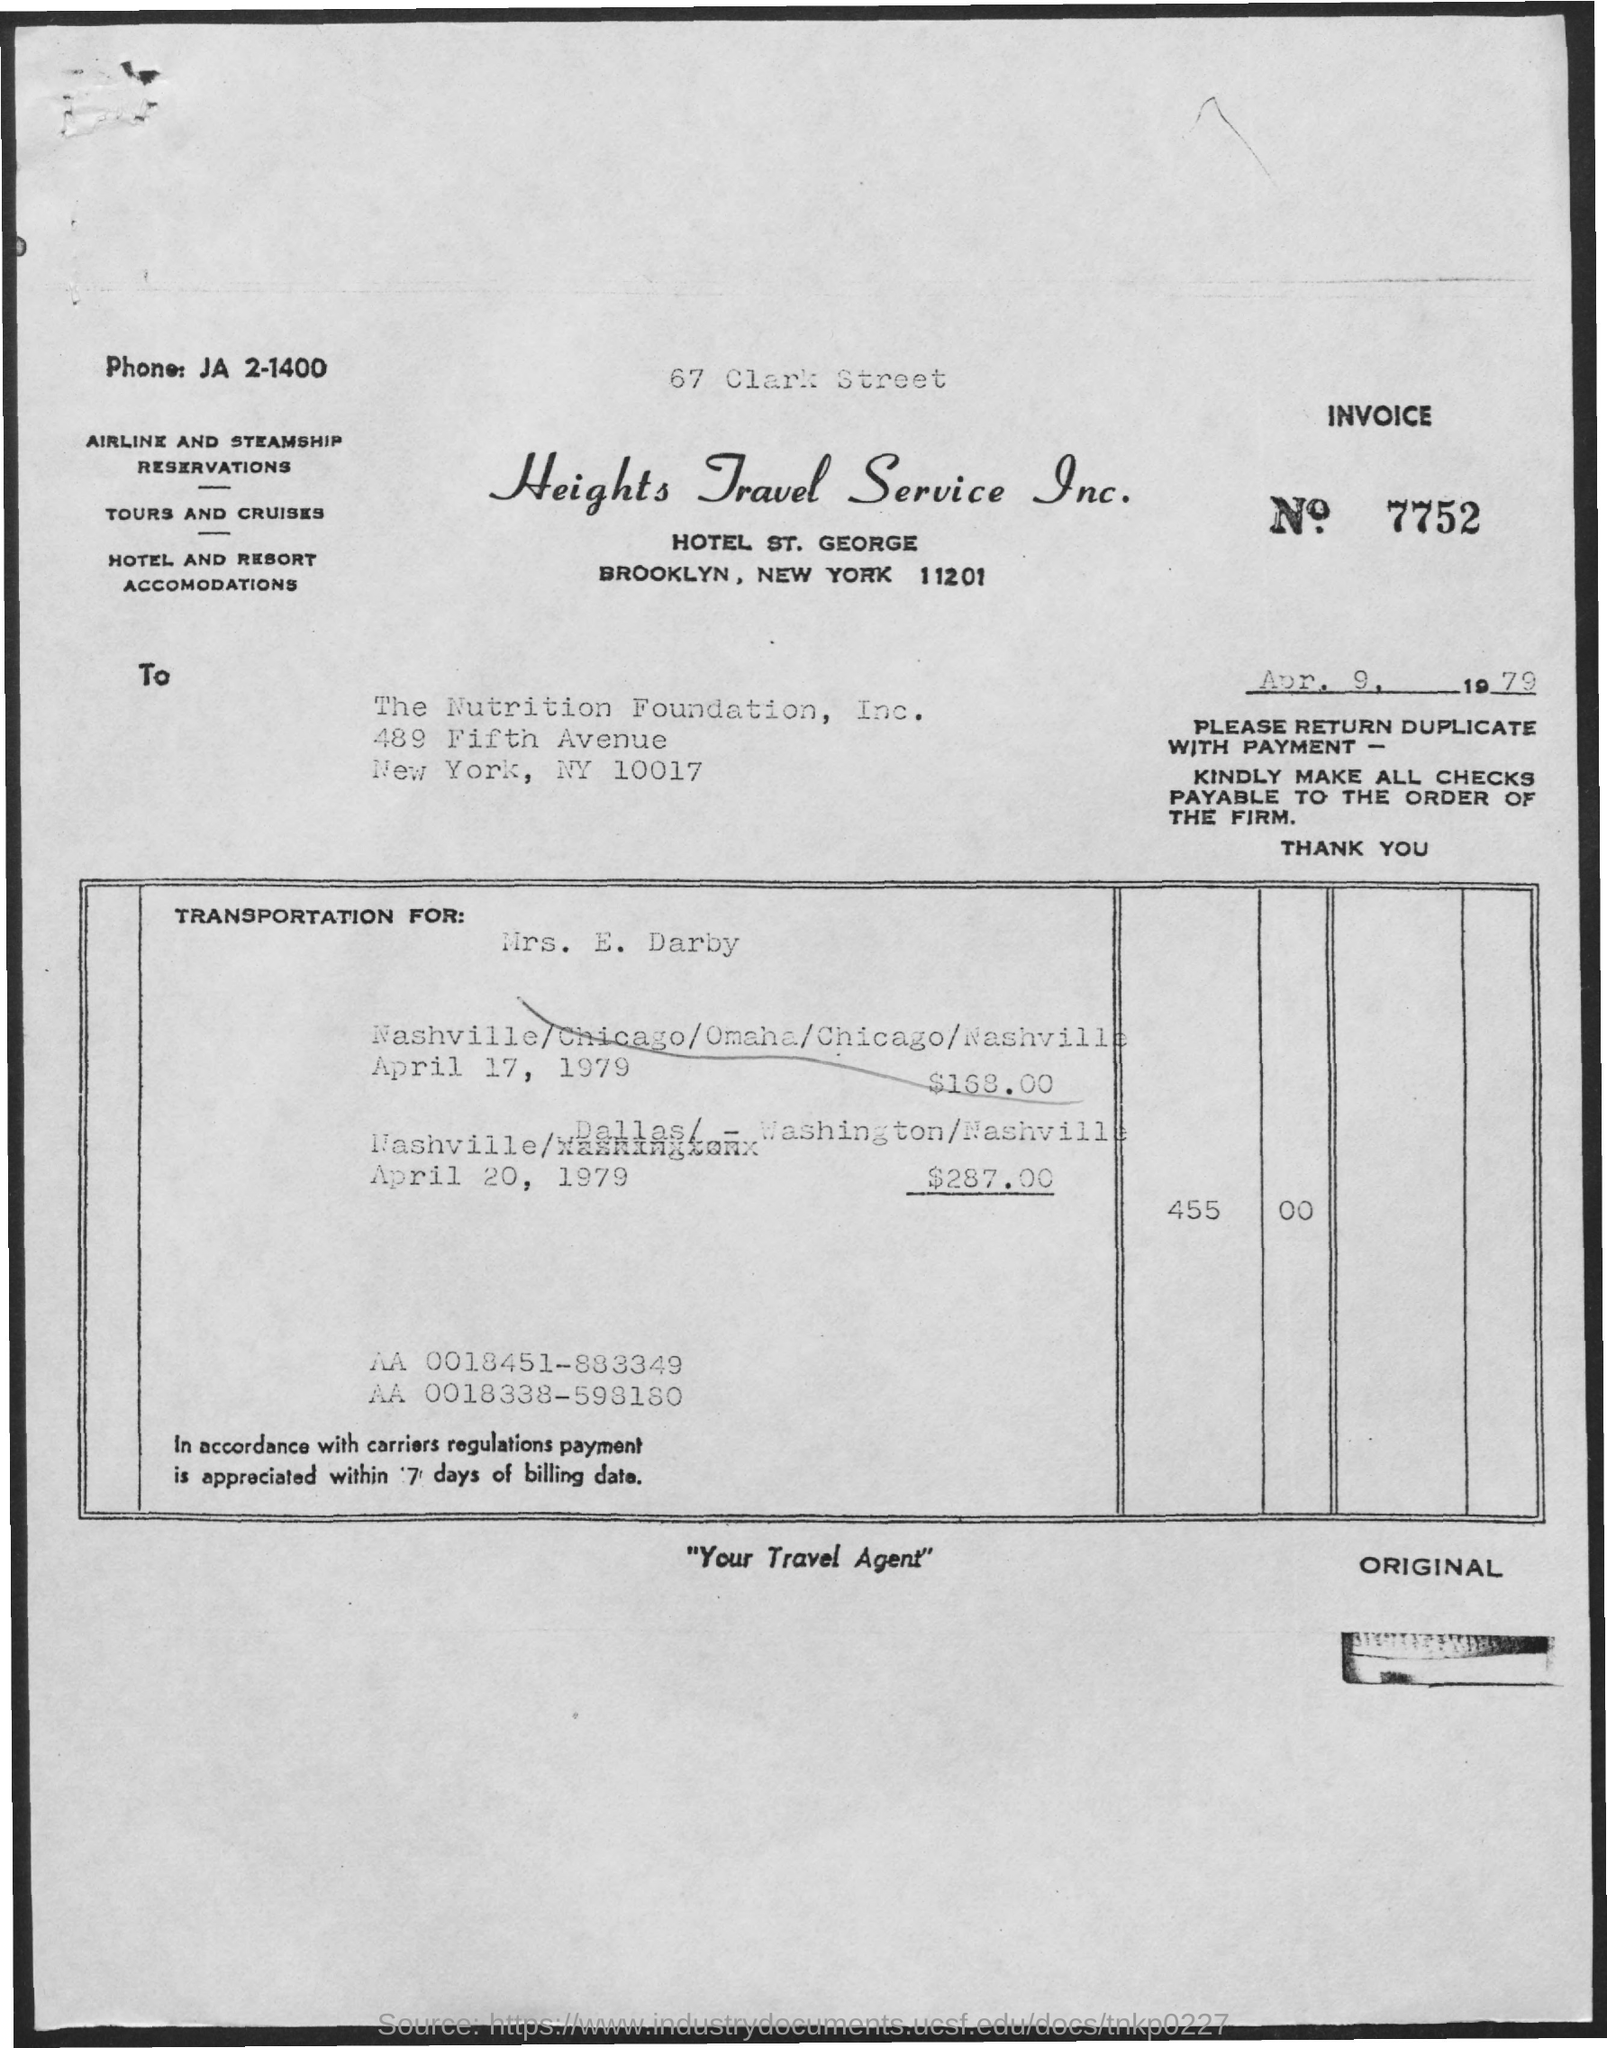Highlight a few significant elements in this photo. The invoice amount for transportation on April 17, 1979 for Mrs. E. Darby was $168.00. The invoice number mentioned in this document is 7752. The invoice amount for transportation on April 20, 1979 for Mrs. E. Darby was $287.00. The phone number mentioned in this document is JA 2-1400. The issued date of the invoice is April 9, 1979. 